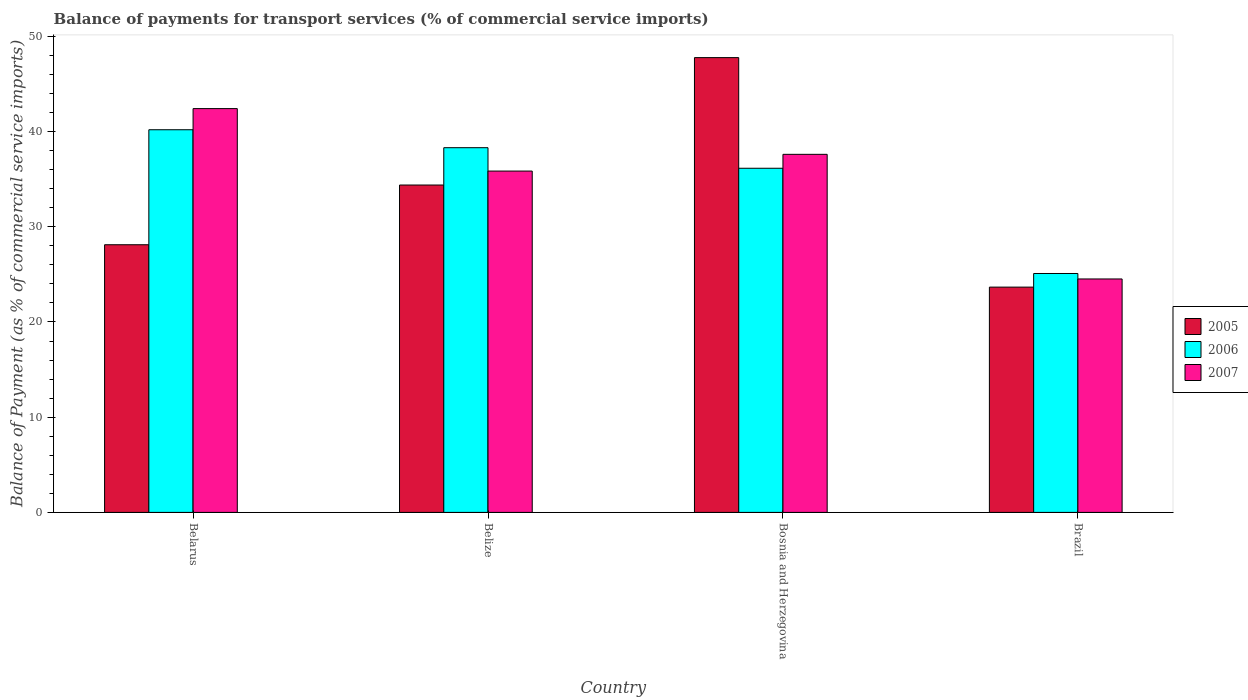How many groups of bars are there?
Your answer should be very brief. 4. Are the number of bars on each tick of the X-axis equal?
Provide a succinct answer. Yes. How many bars are there on the 3rd tick from the left?
Your response must be concise. 3. How many bars are there on the 1st tick from the right?
Your answer should be very brief. 3. What is the label of the 1st group of bars from the left?
Give a very brief answer. Belarus. What is the balance of payments for transport services in 2005 in Belarus?
Offer a terse response. 28.11. Across all countries, what is the maximum balance of payments for transport services in 2005?
Offer a terse response. 47.76. Across all countries, what is the minimum balance of payments for transport services in 2005?
Your response must be concise. 23.66. In which country was the balance of payments for transport services in 2006 maximum?
Your answer should be compact. Belarus. In which country was the balance of payments for transport services in 2005 minimum?
Make the answer very short. Brazil. What is the total balance of payments for transport services in 2005 in the graph?
Your answer should be compact. 133.92. What is the difference between the balance of payments for transport services in 2007 in Bosnia and Herzegovina and that in Brazil?
Make the answer very short. 13.09. What is the difference between the balance of payments for transport services in 2007 in Brazil and the balance of payments for transport services in 2005 in Bosnia and Herzegovina?
Provide a succinct answer. -23.25. What is the average balance of payments for transport services in 2007 per country?
Your answer should be very brief. 35.09. What is the difference between the balance of payments for transport services of/in 2007 and balance of payments for transport services of/in 2006 in Belarus?
Give a very brief answer. 2.22. What is the ratio of the balance of payments for transport services in 2005 in Bosnia and Herzegovina to that in Brazil?
Keep it short and to the point. 2.02. Is the balance of payments for transport services in 2006 in Belize less than that in Bosnia and Herzegovina?
Provide a short and direct response. No. Is the difference between the balance of payments for transport services in 2007 in Belarus and Bosnia and Herzegovina greater than the difference between the balance of payments for transport services in 2006 in Belarus and Bosnia and Herzegovina?
Provide a short and direct response. Yes. What is the difference between the highest and the second highest balance of payments for transport services in 2007?
Give a very brief answer. 6.56. What is the difference between the highest and the lowest balance of payments for transport services in 2007?
Offer a very short reply. 17.89. In how many countries, is the balance of payments for transport services in 2005 greater than the average balance of payments for transport services in 2005 taken over all countries?
Offer a very short reply. 2. How many bars are there?
Offer a very short reply. 12. How many countries are there in the graph?
Provide a succinct answer. 4. Does the graph contain any zero values?
Offer a very short reply. No. Where does the legend appear in the graph?
Your answer should be compact. Center right. How are the legend labels stacked?
Ensure brevity in your answer.  Vertical. What is the title of the graph?
Ensure brevity in your answer.  Balance of payments for transport services (% of commercial service imports). What is the label or title of the Y-axis?
Offer a terse response. Balance of Payment (as % of commercial service imports). What is the Balance of Payment (as % of commercial service imports) in 2005 in Belarus?
Your response must be concise. 28.11. What is the Balance of Payment (as % of commercial service imports) in 2006 in Belarus?
Offer a terse response. 40.19. What is the Balance of Payment (as % of commercial service imports) of 2007 in Belarus?
Offer a very short reply. 42.41. What is the Balance of Payment (as % of commercial service imports) in 2005 in Belize?
Your answer should be compact. 34.38. What is the Balance of Payment (as % of commercial service imports) in 2006 in Belize?
Offer a terse response. 38.3. What is the Balance of Payment (as % of commercial service imports) in 2007 in Belize?
Your answer should be compact. 35.85. What is the Balance of Payment (as % of commercial service imports) of 2005 in Bosnia and Herzegovina?
Offer a terse response. 47.76. What is the Balance of Payment (as % of commercial service imports) in 2006 in Bosnia and Herzegovina?
Offer a terse response. 36.14. What is the Balance of Payment (as % of commercial service imports) of 2007 in Bosnia and Herzegovina?
Give a very brief answer. 37.6. What is the Balance of Payment (as % of commercial service imports) in 2005 in Brazil?
Offer a terse response. 23.66. What is the Balance of Payment (as % of commercial service imports) in 2006 in Brazil?
Provide a short and direct response. 25.09. What is the Balance of Payment (as % of commercial service imports) of 2007 in Brazil?
Your answer should be compact. 24.52. Across all countries, what is the maximum Balance of Payment (as % of commercial service imports) of 2005?
Your answer should be very brief. 47.76. Across all countries, what is the maximum Balance of Payment (as % of commercial service imports) of 2006?
Provide a short and direct response. 40.19. Across all countries, what is the maximum Balance of Payment (as % of commercial service imports) of 2007?
Your response must be concise. 42.41. Across all countries, what is the minimum Balance of Payment (as % of commercial service imports) of 2005?
Provide a succinct answer. 23.66. Across all countries, what is the minimum Balance of Payment (as % of commercial service imports) of 2006?
Provide a short and direct response. 25.09. Across all countries, what is the minimum Balance of Payment (as % of commercial service imports) of 2007?
Ensure brevity in your answer.  24.52. What is the total Balance of Payment (as % of commercial service imports) of 2005 in the graph?
Offer a very short reply. 133.92. What is the total Balance of Payment (as % of commercial service imports) of 2006 in the graph?
Offer a very short reply. 139.72. What is the total Balance of Payment (as % of commercial service imports) in 2007 in the graph?
Offer a terse response. 140.38. What is the difference between the Balance of Payment (as % of commercial service imports) in 2005 in Belarus and that in Belize?
Offer a terse response. -6.27. What is the difference between the Balance of Payment (as % of commercial service imports) of 2006 in Belarus and that in Belize?
Provide a succinct answer. 1.89. What is the difference between the Balance of Payment (as % of commercial service imports) of 2007 in Belarus and that in Belize?
Your answer should be compact. 6.56. What is the difference between the Balance of Payment (as % of commercial service imports) in 2005 in Belarus and that in Bosnia and Herzegovina?
Provide a succinct answer. -19.65. What is the difference between the Balance of Payment (as % of commercial service imports) in 2006 in Belarus and that in Bosnia and Herzegovina?
Keep it short and to the point. 4.04. What is the difference between the Balance of Payment (as % of commercial service imports) in 2007 in Belarus and that in Bosnia and Herzegovina?
Ensure brevity in your answer.  4.8. What is the difference between the Balance of Payment (as % of commercial service imports) of 2005 in Belarus and that in Brazil?
Give a very brief answer. 4.45. What is the difference between the Balance of Payment (as % of commercial service imports) in 2006 in Belarus and that in Brazil?
Make the answer very short. 15.1. What is the difference between the Balance of Payment (as % of commercial service imports) in 2007 in Belarus and that in Brazil?
Offer a very short reply. 17.89. What is the difference between the Balance of Payment (as % of commercial service imports) of 2005 in Belize and that in Bosnia and Herzegovina?
Offer a very short reply. -13.38. What is the difference between the Balance of Payment (as % of commercial service imports) of 2006 in Belize and that in Bosnia and Herzegovina?
Your response must be concise. 2.16. What is the difference between the Balance of Payment (as % of commercial service imports) of 2007 in Belize and that in Bosnia and Herzegovina?
Offer a terse response. -1.76. What is the difference between the Balance of Payment (as % of commercial service imports) in 2005 in Belize and that in Brazil?
Give a very brief answer. 10.72. What is the difference between the Balance of Payment (as % of commercial service imports) in 2006 in Belize and that in Brazil?
Your answer should be compact. 13.21. What is the difference between the Balance of Payment (as % of commercial service imports) in 2007 in Belize and that in Brazil?
Your response must be concise. 11.33. What is the difference between the Balance of Payment (as % of commercial service imports) in 2005 in Bosnia and Herzegovina and that in Brazil?
Provide a short and direct response. 24.1. What is the difference between the Balance of Payment (as % of commercial service imports) in 2006 in Bosnia and Herzegovina and that in Brazil?
Offer a terse response. 11.05. What is the difference between the Balance of Payment (as % of commercial service imports) of 2007 in Bosnia and Herzegovina and that in Brazil?
Your response must be concise. 13.09. What is the difference between the Balance of Payment (as % of commercial service imports) in 2005 in Belarus and the Balance of Payment (as % of commercial service imports) in 2006 in Belize?
Offer a very short reply. -10.19. What is the difference between the Balance of Payment (as % of commercial service imports) of 2005 in Belarus and the Balance of Payment (as % of commercial service imports) of 2007 in Belize?
Your answer should be compact. -7.74. What is the difference between the Balance of Payment (as % of commercial service imports) in 2006 in Belarus and the Balance of Payment (as % of commercial service imports) in 2007 in Belize?
Give a very brief answer. 4.34. What is the difference between the Balance of Payment (as % of commercial service imports) of 2005 in Belarus and the Balance of Payment (as % of commercial service imports) of 2006 in Bosnia and Herzegovina?
Offer a terse response. -8.03. What is the difference between the Balance of Payment (as % of commercial service imports) of 2005 in Belarus and the Balance of Payment (as % of commercial service imports) of 2007 in Bosnia and Herzegovina?
Give a very brief answer. -9.49. What is the difference between the Balance of Payment (as % of commercial service imports) of 2006 in Belarus and the Balance of Payment (as % of commercial service imports) of 2007 in Bosnia and Herzegovina?
Offer a very short reply. 2.58. What is the difference between the Balance of Payment (as % of commercial service imports) of 2005 in Belarus and the Balance of Payment (as % of commercial service imports) of 2006 in Brazil?
Keep it short and to the point. 3.02. What is the difference between the Balance of Payment (as % of commercial service imports) of 2005 in Belarus and the Balance of Payment (as % of commercial service imports) of 2007 in Brazil?
Your response must be concise. 3.59. What is the difference between the Balance of Payment (as % of commercial service imports) of 2006 in Belarus and the Balance of Payment (as % of commercial service imports) of 2007 in Brazil?
Your answer should be compact. 15.67. What is the difference between the Balance of Payment (as % of commercial service imports) in 2005 in Belize and the Balance of Payment (as % of commercial service imports) in 2006 in Bosnia and Herzegovina?
Offer a terse response. -1.76. What is the difference between the Balance of Payment (as % of commercial service imports) of 2005 in Belize and the Balance of Payment (as % of commercial service imports) of 2007 in Bosnia and Herzegovina?
Your answer should be very brief. -3.22. What is the difference between the Balance of Payment (as % of commercial service imports) of 2006 in Belize and the Balance of Payment (as % of commercial service imports) of 2007 in Bosnia and Herzegovina?
Provide a short and direct response. 0.7. What is the difference between the Balance of Payment (as % of commercial service imports) in 2005 in Belize and the Balance of Payment (as % of commercial service imports) in 2006 in Brazil?
Offer a terse response. 9.29. What is the difference between the Balance of Payment (as % of commercial service imports) of 2005 in Belize and the Balance of Payment (as % of commercial service imports) of 2007 in Brazil?
Offer a terse response. 9.87. What is the difference between the Balance of Payment (as % of commercial service imports) of 2006 in Belize and the Balance of Payment (as % of commercial service imports) of 2007 in Brazil?
Offer a terse response. 13.79. What is the difference between the Balance of Payment (as % of commercial service imports) of 2005 in Bosnia and Herzegovina and the Balance of Payment (as % of commercial service imports) of 2006 in Brazil?
Provide a succinct answer. 22.67. What is the difference between the Balance of Payment (as % of commercial service imports) in 2005 in Bosnia and Herzegovina and the Balance of Payment (as % of commercial service imports) in 2007 in Brazil?
Provide a succinct answer. 23.25. What is the difference between the Balance of Payment (as % of commercial service imports) in 2006 in Bosnia and Herzegovina and the Balance of Payment (as % of commercial service imports) in 2007 in Brazil?
Ensure brevity in your answer.  11.63. What is the average Balance of Payment (as % of commercial service imports) in 2005 per country?
Your response must be concise. 33.48. What is the average Balance of Payment (as % of commercial service imports) of 2006 per country?
Keep it short and to the point. 34.93. What is the average Balance of Payment (as % of commercial service imports) in 2007 per country?
Make the answer very short. 35.09. What is the difference between the Balance of Payment (as % of commercial service imports) in 2005 and Balance of Payment (as % of commercial service imports) in 2006 in Belarus?
Offer a very short reply. -12.08. What is the difference between the Balance of Payment (as % of commercial service imports) of 2005 and Balance of Payment (as % of commercial service imports) of 2007 in Belarus?
Ensure brevity in your answer.  -14.3. What is the difference between the Balance of Payment (as % of commercial service imports) in 2006 and Balance of Payment (as % of commercial service imports) in 2007 in Belarus?
Ensure brevity in your answer.  -2.22. What is the difference between the Balance of Payment (as % of commercial service imports) of 2005 and Balance of Payment (as % of commercial service imports) of 2006 in Belize?
Make the answer very short. -3.92. What is the difference between the Balance of Payment (as % of commercial service imports) in 2005 and Balance of Payment (as % of commercial service imports) in 2007 in Belize?
Provide a succinct answer. -1.46. What is the difference between the Balance of Payment (as % of commercial service imports) of 2006 and Balance of Payment (as % of commercial service imports) of 2007 in Belize?
Offer a very short reply. 2.46. What is the difference between the Balance of Payment (as % of commercial service imports) in 2005 and Balance of Payment (as % of commercial service imports) in 2006 in Bosnia and Herzegovina?
Provide a succinct answer. 11.62. What is the difference between the Balance of Payment (as % of commercial service imports) of 2005 and Balance of Payment (as % of commercial service imports) of 2007 in Bosnia and Herzegovina?
Provide a succinct answer. 10.16. What is the difference between the Balance of Payment (as % of commercial service imports) in 2006 and Balance of Payment (as % of commercial service imports) in 2007 in Bosnia and Herzegovina?
Give a very brief answer. -1.46. What is the difference between the Balance of Payment (as % of commercial service imports) in 2005 and Balance of Payment (as % of commercial service imports) in 2006 in Brazil?
Offer a very short reply. -1.43. What is the difference between the Balance of Payment (as % of commercial service imports) in 2005 and Balance of Payment (as % of commercial service imports) in 2007 in Brazil?
Your answer should be compact. -0.86. What is the difference between the Balance of Payment (as % of commercial service imports) in 2006 and Balance of Payment (as % of commercial service imports) in 2007 in Brazil?
Ensure brevity in your answer.  0.57. What is the ratio of the Balance of Payment (as % of commercial service imports) of 2005 in Belarus to that in Belize?
Ensure brevity in your answer.  0.82. What is the ratio of the Balance of Payment (as % of commercial service imports) of 2006 in Belarus to that in Belize?
Give a very brief answer. 1.05. What is the ratio of the Balance of Payment (as % of commercial service imports) in 2007 in Belarus to that in Belize?
Give a very brief answer. 1.18. What is the ratio of the Balance of Payment (as % of commercial service imports) in 2005 in Belarus to that in Bosnia and Herzegovina?
Your answer should be compact. 0.59. What is the ratio of the Balance of Payment (as % of commercial service imports) of 2006 in Belarus to that in Bosnia and Herzegovina?
Offer a very short reply. 1.11. What is the ratio of the Balance of Payment (as % of commercial service imports) of 2007 in Belarus to that in Bosnia and Herzegovina?
Offer a very short reply. 1.13. What is the ratio of the Balance of Payment (as % of commercial service imports) of 2005 in Belarus to that in Brazil?
Offer a very short reply. 1.19. What is the ratio of the Balance of Payment (as % of commercial service imports) of 2006 in Belarus to that in Brazil?
Ensure brevity in your answer.  1.6. What is the ratio of the Balance of Payment (as % of commercial service imports) of 2007 in Belarus to that in Brazil?
Ensure brevity in your answer.  1.73. What is the ratio of the Balance of Payment (as % of commercial service imports) in 2005 in Belize to that in Bosnia and Herzegovina?
Make the answer very short. 0.72. What is the ratio of the Balance of Payment (as % of commercial service imports) of 2006 in Belize to that in Bosnia and Herzegovina?
Your response must be concise. 1.06. What is the ratio of the Balance of Payment (as % of commercial service imports) of 2007 in Belize to that in Bosnia and Herzegovina?
Your answer should be compact. 0.95. What is the ratio of the Balance of Payment (as % of commercial service imports) in 2005 in Belize to that in Brazil?
Keep it short and to the point. 1.45. What is the ratio of the Balance of Payment (as % of commercial service imports) of 2006 in Belize to that in Brazil?
Your response must be concise. 1.53. What is the ratio of the Balance of Payment (as % of commercial service imports) of 2007 in Belize to that in Brazil?
Your answer should be compact. 1.46. What is the ratio of the Balance of Payment (as % of commercial service imports) in 2005 in Bosnia and Herzegovina to that in Brazil?
Give a very brief answer. 2.02. What is the ratio of the Balance of Payment (as % of commercial service imports) in 2006 in Bosnia and Herzegovina to that in Brazil?
Give a very brief answer. 1.44. What is the ratio of the Balance of Payment (as % of commercial service imports) of 2007 in Bosnia and Herzegovina to that in Brazil?
Your answer should be very brief. 1.53. What is the difference between the highest and the second highest Balance of Payment (as % of commercial service imports) of 2005?
Provide a succinct answer. 13.38. What is the difference between the highest and the second highest Balance of Payment (as % of commercial service imports) in 2006?
Provide a succinct answer. 1.89. What is the difference between the highest and the second highest Balance of Payment (as % of commercial service imports) of 2007?
Provide a short and direct response. 4.8. What is the difference between the highest and the lowest Balance of Payment (as % of commercial service imports) of 2005?
Your answer should be compact. 24.1. What is the difference between the highest and the lowest Balance of Payment (as % of commercial service imports) of 2006?
Offer a terse response. 15.1. What is the difference between the highest and the lowest Balance of Payment (as % of commercial service imports) in 2007?
Give a very brief answer. 17.89. 